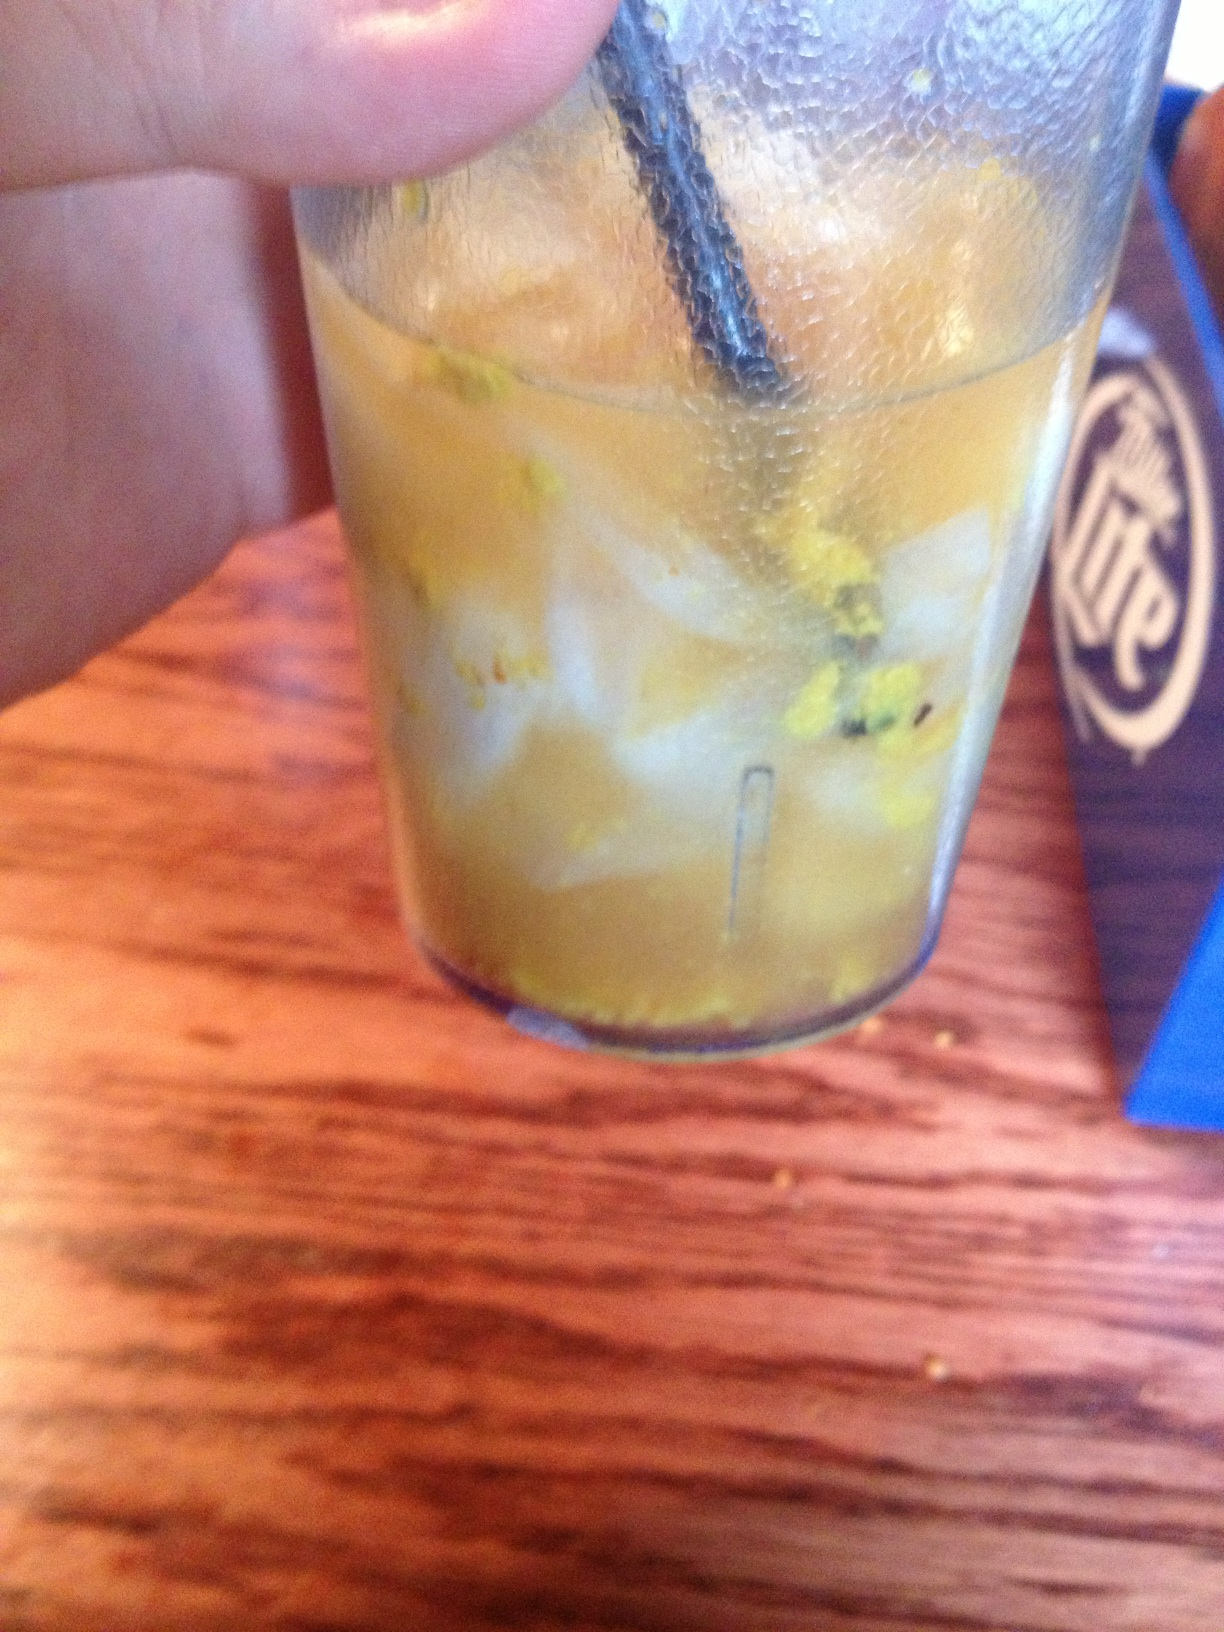What is this drink supposed to be? It looks strange. This drink seems a bit unusual. It appears to have some kind of grated zest or particles in it. It might be a specialty drink with ingredients like orange zest or ground ginger giving it a distinct appearance. You should check with the server to confirm what it is and whether it's prepared correctly. Is it safe to drink something with floating particles like that? The safety of consuming a drink with floating particles depends on what those particles are. Ingredients like fruit zest or herbs can be safe, but if you're unsure about the source of the particles or if they make the drink taste off, it's best to err on the side of caution and either ask for clarification or request a different beverage. Could this be an attempt at a creative or experimental drink? It's possible that the restaurant is experimenting with new ingredients or presentation styles, which might result in a drink with unusual elements. If this is the case, the server should be able to explain the concept behind it and help you decide if it's something you'd enjoy. 